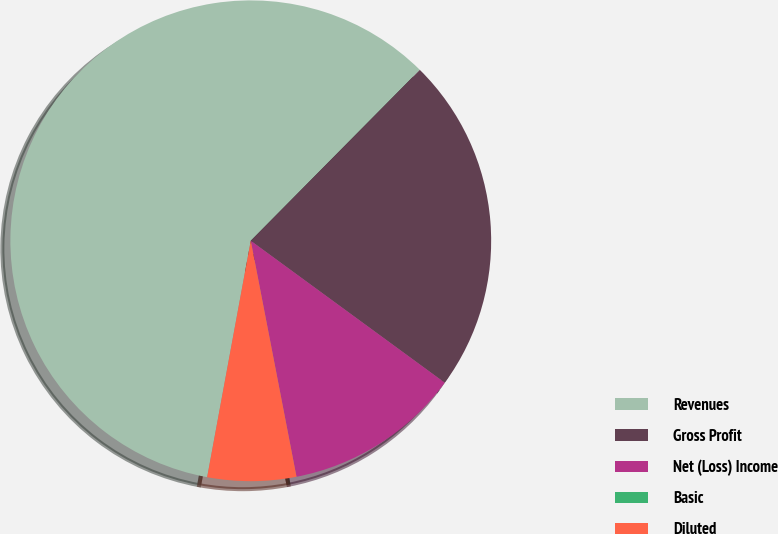Convert chart to OTSL. <chart><loc_0><loc_0><loc_500><loc_500><pie_chart><fcel>Revenues<fcel>Gross Profit<fcel>Net (Loss) Income<fcel>Basic<fcel>Diluted<nl><fcel>59.51%<fcel>22.64%<fcel>11.9%<fcel>0.0%<fcel>5.95%<nl></chart> 